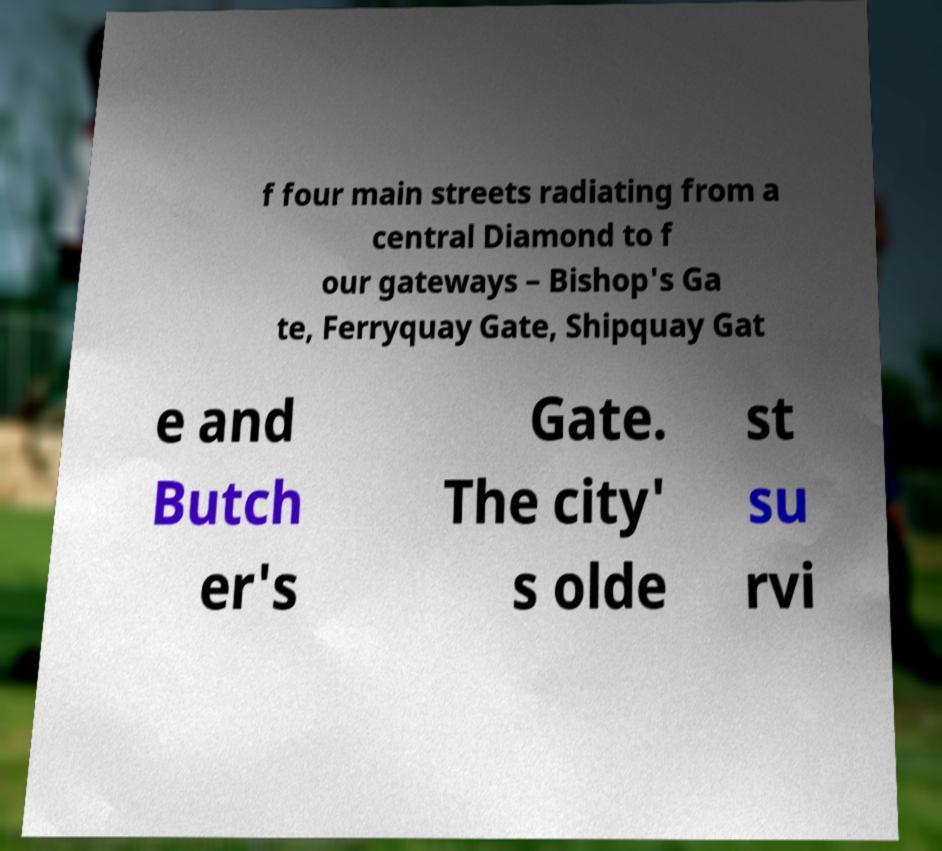Please read and relay the text visible in this image. What does it say? f four main streets radiating from a central Diamond to f our gateways – Bishop's Ga te, Ferryquay Gate, Shipquay Gat e and Butch er's Gate. The city' s olde st su rvi 